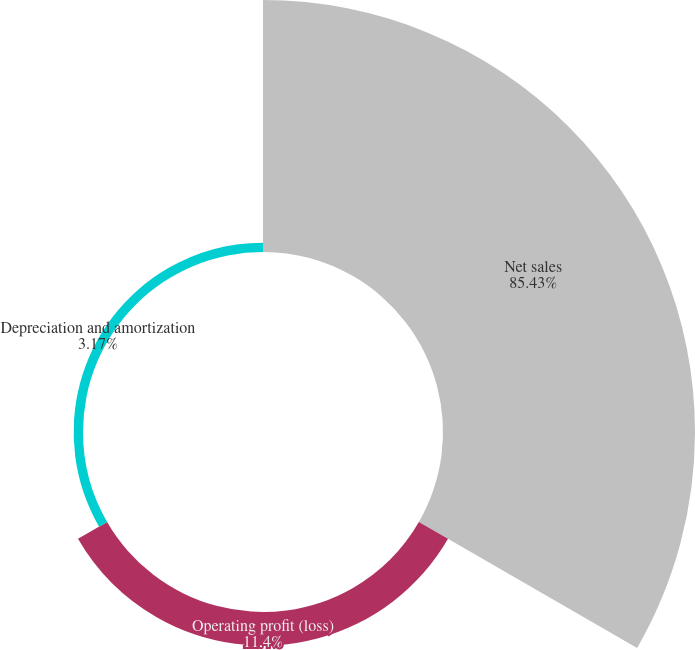<chart> <loc_0><loc_0><loc_500><loc_500><pie_chart><fcel>Net sales<fcel>Operating profit (loss)<fcel>Depreciation and amortization<nl><fcel>85.43%<fcel>11.4%<fcel>3.17%<nl></chart> 